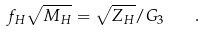<formula> <loc_0><loc_0><loc_500><loc_500>f _ { H } \sqrt { M _ { H } } = \sqrt { Z _ { H } } / G _ { 3 } \quad .</formula> 